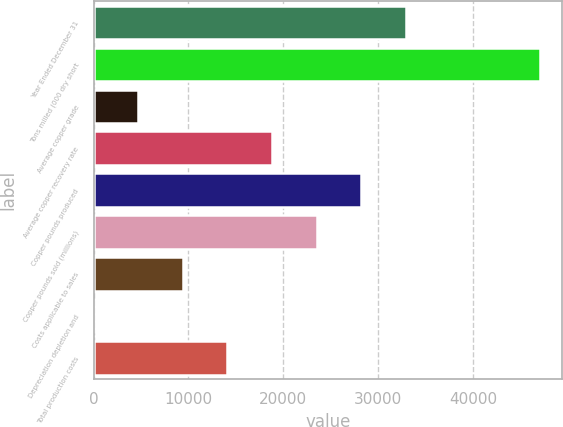Convert chart. <chart><loc_0><loc_0><loc_500><loc_500><bar_chart><fcel>Year Ended December 31<fcel>Tons milled (000 dry short<fcel>Average copper grade<fcel>Average copper recovery rate<fcel>Copper pounds produced<fcel>Copper pounds sold (millions)<fcel>Costs applicable to sales<fcel>Depreciation depletion and<fcel>Total production costs<nl><fcel>32918.2<fcel>47026<fcel>4702.73<fcel>18810.5<fcel>28215.7<fcel>23513.1<fcel>9405.31<fcel>0.15<fcel>14107.9<nl></chart> 